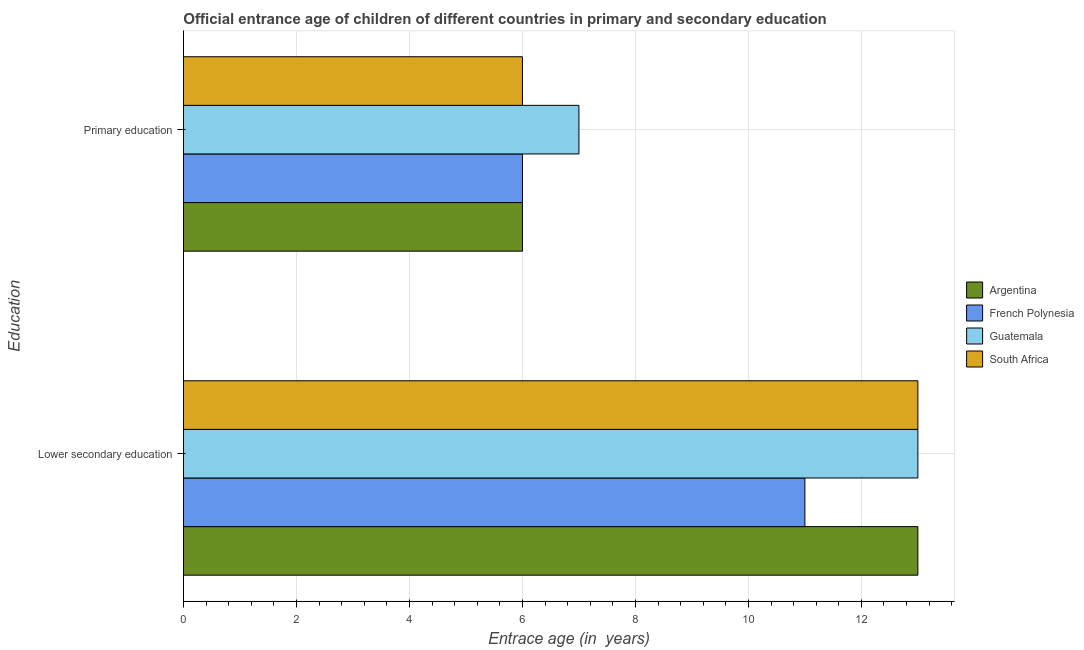How many different coloured bars are there?
Keep it short and to the point. 4. How many groups of bars are there?
Make the answer very short. 2. Are the number of bars per tick equal to the number of legend labels?
Offer a very short reply. Yes. How many bars are there on the 1st tick from the bottom?
Make the answer very short. 4. What is the label of the 1st group of bars from the top?
Ensure brevity in your answer.  Primary education. What is the entrance age of children in lower secondary education in Argentina?
Provide a short and direct response. 13. Across all countries, what is the maximum entrance age of children in lower secondary education?
Provide a succinct answer. 13. Across all countries, what is the minimum entrance age of children in lower secondary education?
Give a very brief answer. 11. In which country was the entrance age of children in lower secondary education maximum?
Keep it short and to the point. Argentina. In which country was the entrance age of chiildren in primary education minimum?
Your answer should be compact. Argentina. What is the total entrance age of chiildren in primary education in the graph?
Give a very brief answer. 25. What is the difference between the entrance age of children in lower secondary education in French Polynesia and the entrance age of chiildren in primary education in Guatemala?
Your response must be concise. 4. What is the average entrance age of children in lower secondary education per country?
Ensure brevity in your answer.  12.5. What is the difference between the entrance age of children in lower secondary education and entrance age of chiildren in primary education in Argentina?
Keep it short and to the point. 7. What is the ratio of the entrance age of children in lower secondary education in French Polynesia to that in Guatemala?
Offer a very short reply. 0.85. In how many countries, is the entrance age of chiildren in primary education greater than the average entrance age of chiildren in primary education taken over all countries?
Your answer should be compact. 1. What does the 2nd bar from the top in Primary education represents?
Provide a succinct answer. Guatemala. What does the 2nd bar from the bottom in Primary education represents?
Provide a succinct answer. French Polynesia. How many countries are there in the graph?
Offer a terse response. 4. What is the difference between two consecutive major ticks on the X-axis?
Your answer should be compact. 2. Does the graph contain grids?
Your response must be concise. Yes. Where does the legend appear in the graph?
Keep it short and to the point. Center right. How are the legend labels stacked?
Give a very brief answer. Vertical. What is the title of the graph?
Your response must be concise. Official entrance age of children of different countries in primary and secondary education. Does "Cote d'Ivoire" appear as one of the legend labels in the graph?
Provide a succinct answer. No. What is the label or title of the X-axis?
Offer a terse response. Entrace age (in  years). What is the label or title of the Y-axis?
Provide a succinct answer. Education. What is the Entrace age (in  years) of French Polynesia in Lower secondary education?
Give a very brief answer. 11. What is the Entrace age (in  years) of French Polynesia in Primary education?
Offer a very short reply. 6. What is the Entrace age (in  years) in Guatemala in Primary education?
Provide a succinct answer. 7. What is the Entrace age (in  years) of South Africa in Primary education?
Your response must be concise. 6. Across all Education, what is the maximum Entrace age (in  years) of French Polynesia?
Keep it short and to the point. 11. Across all Education, what is the maximum Entrace age (in  years) of South Africa?
Make the answer very short. 13. Across all Education, what is the minimum Entrace age (in  years) in French Polynesia?
Provide a succinct answer. 6. Across all Education, what is the minimum Entrace age (in  years) in Guatemala?
Keep it short and to the point. 7. Across all Education, what is the minimum Entrace age (in  years) of South Africa?
Make the answer very short. 6. What is the total Entrace age (in  years) in South Africa in the graph?
Keep it short and to the point. 19. What is the difference between the Entrace age (in  years) of Argentina in Lower secondary education and that in Primary education?
Your answer should be compact. 7. What is the difference between the Entrace age (in  years) in French Polynesia in Lower secondary education and that in Primary education?
Your answer should be very brief. 5. What is the difference between the Entrace age (in  years) in Guatemala in Lower secondary education and that in Primary education?
Offer a very short reply. 6. What is the difference between the Entrace age (in  years) in Argentina in Lower secondary education and the Entrace age (in  years) in French Polynesia in Primary education?
Keep it short and to the point. 7. What is the difference between the Entrace age (in  years) in Argentina in Lower secondary education and the Entrace age (in  years) in Guatemala in Primary education?
Keep it short and to the point. 6. What is the difference between the Entrace age (in  years) of French Polynesia in Lower secondary education and the Entrace age (in  years) of Guatemala in Primary education?
Give a very brief answer. 4. What is the difference between the Entrace age (in  years) of Guatemala in Lower secondary education and the Entrace age (in  years) of South Africa in Primary education?
Offer a terse response. 7. What is the average Entrace age (in  years) in French Polynesia per Education?
Keep it short and to the point. 8.5. What is the difference between the Entrace age (in  years) in Argentina and Entrace age (in  years) in Guatemala in Lower secondary education?
Give a very brief answer. 0. What is the difference between the Entrace age (in  years) of Argentina and Entrace age (in  years) of South Africa in Lower secondary education?
Make the answer very short. 0. What is the difference between the Entrace age (in  years) of French Polynesia and Entrace age (in  years) of Guatemala in Lower secondary education?
Ensure brevity in your answer.  -2. What is the difference between the Entrace age (in  years) of Argentina and Entrace age (in  years) of Guatemala in Primary education?
Your answer should be compact. -1. What is the difference between the Entrace age (in  years) of Argentina and Entrace age (in  years) of South Africa in Primary education?
Your response must be concise. 0. What is the difference between the Entrace age (in  years) in French Polynesia and Entrace age (in  years) in Guatemala in Primary education?
Your answer should be compact. -1. What is the difference between the Entrace age (in  years) of French Polynesia and Entrace age (in  years) of South Africa in Primary education?
Keep it short and to the point. 0. What is the difference between the Entrace age (in  years) in Guatemala and Entrace age (in  years) in South Africa in Primary education?
Your response must be concise. 1. What is the ratio of the Entrace age (in  years) of Argentina in Lower secondary education to that in Primary education?
Your answer should be very brief. 2.17. What is the ratio of the Entrace age (in  years) of French Polynesia in Lower secondary education to that in Primary education?
Offer a terse response. 1.83. What is the ratio of the Entrace age (in  years) in Guatemala in Lower secondary education to that in Primary education?
Offer a very short reply. 1.86. What is the ratio of the Entrace age (in  years) of South Africa in Lower secondary education to that in Primary education?
Your response must be concise. 2.17. What is the difference between the highest and the second highest Entrace age (in  years) of South Africa?
Your answer should be compact. 7. What is the difference between the highest and the lowest Entrace age (in  years) of Argentina?
Make the answer very short. 7. What is the difference between the highest and the lowest Entrace age (in  years) of French Polynesia?
Your answer should be compact. 5. What is the difference between the highest and the lowest Entrace age (in  years) in Guatemala?
Offer a terse response. 6. 